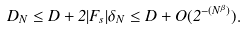Convert formula to latex. <formula><loc_0><loc_0><loc_500><loc_500>D _ { N } \leq D + 2 | F _ { s } | \delta _ { N } \leq D + O ( 2 ^ { - ( N ^ { \beta } ) } ) .</formula> 